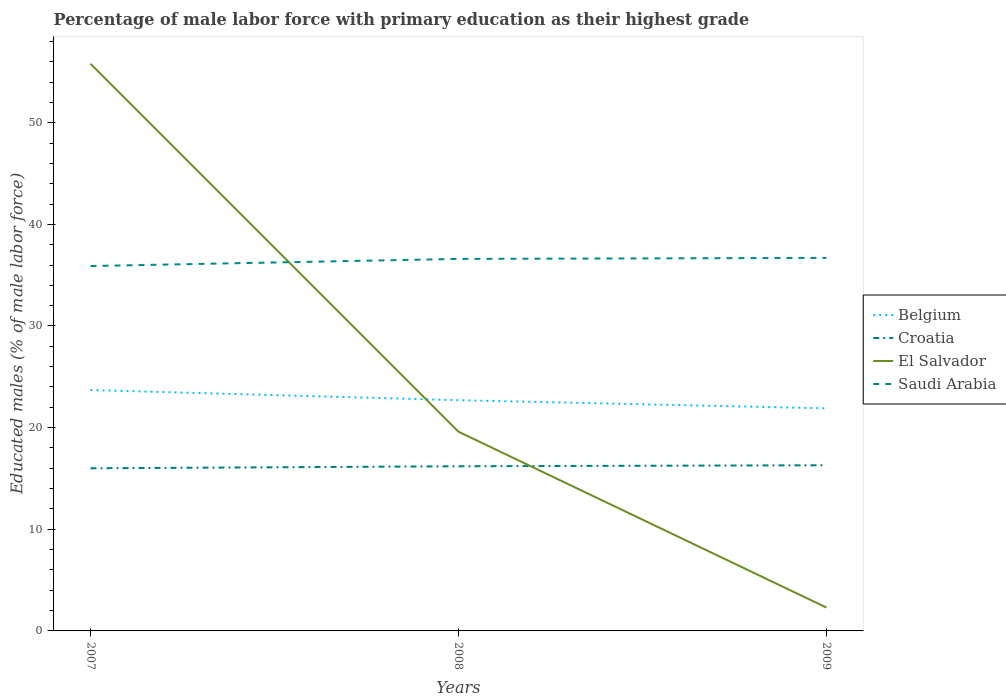How many different coloured lines are there?
Your answer should be compact. 4. Is the number of lines equal to the number of legend labels?
Your response must be concise. Yes. What is the total percentage of male labor force with primary education in Saudi Arabia in the graph?
Ensure brevity in your answer.  -0.8. What is the difference between the highest and the second highest percentage of male labor force with primary education in El Salvador?
Ensure brevity in your answer.  53.5. Does the graph contain any zero values?
Keep it short and to the point. No. Does the graph contain grids?
Offer a very short reply. No. How are the legend labels stacked?
Offer a very short reply. Vertical. What is the title of the graph?
Provide a succinct answer. Percentage of male labor force with primary education as their highest grade. What is the label or title of the X-axis?
Ensure brevity in your answer.  Years. What is the label or title of the Y-axis?
Ensure brevity in your answer.  Educated males (% of male labor force). What is the Educated males (% of male labor force) in Belgium in 2007?
Offer a terse response. 23.7. What is the Educated males (% of male labor force) in El Salvador in 2007?
Keep it short and to the point. 55.8. What is the Educated males (% of male labor force) in Saudi Arabia in 2007?
Make the answer very short. 35.9. What is the Educated males (% of male labor force) of Belgium in 2008?
Provide a short and direct response. 22.7. What is the Educated males (% of male labor force) of Croatia in 2008?
Offer a very short reply. 16.2. What is the Educated males (% of male labor force) of El Salvador in 2008?
Offer a terse response. 19.6. What is the Educated males (% of male labor force) in Saudi Arabia in 2008?
Your answer should be very brief. 36.6. What is the Educated males (% of male labor force) in Belgium in 2009?
Provide a short and direct response. 21.9. What is the Educated males (% of male labor force) of Croatia in 2009?
Provide a short and direct response. 16.3. What is the Educated males (% of male labor force) in El Salvador in 2009?
Provide a short and direct response. 2.3. What is the Educated males (% of male labor force) in Saudi Arabia in 2009?
Give a very brief answer. 36.7. Across all years, what is the maximum Educated males (% of male labor force) of Belgium?
Provide a succinct answer. 23.7. Across all years, what is the maximum Educated males (% of male labor force) in Croatia?
Your answer should be very brief. 16.3. Across all years, what is the maximum Educated males (% of male labor force) of El Salvador?
Your response must be concise. 55.8. Across all years, what is the maximum Educated males (% of male labor force) of Saudi Arabia?
Your answer should be very brief. 36.7. Across all years, what is the minimum Educated males (% of male labor force) of Belgium?
Your answer should be compact. 21.9. Across all years, what is the minimum Educated males (% of male labor force) in Croatia?
Provide a succinct answer. 16. Across all years, what is the minimum Educated males (% of male labor force) of El Salvador?
Provide a succinct answer. 2.3. Across all years, what is the minimum Educated males (% of male labor force) in Saudi Arabia?
Keep it short and to the point. 35.9. What is the total Educated males (% of male labor force) of Belgium in the graph?
Ensure brevity in your answer.  68.3. What is the total Educated males (% of male labor force) in Croatia in the graph?
Offer a terse response. 48.5. What is the total Educated males (% of male labor force) of El Salvador in the graph?
Your answer should be very brief. 77.7. What is the total Educated males (% of male labor force) in Saudi Arabia in the graph?
Your answer should be very brief. 109.2. What is the difference between the Educated males (% of male labor force) of El Salvador in 2007 and that in 2008?
Provide a succinct answer. 36.2. What is the difference between the Educated males (% of male labor force) of El Salvador in 2007 and that in 2009?
Make the answer very short. 53.5. What is the difference between the Educated males (% of male labor force) in Croatia in 2008 and that in 2009?
Make the answer very short. -0.1. What is the difference between the Educated males (% of male labor force) of El Salvador in 2008 and that in 2009?
Your answer should be very brief. 17.3. What is the difference between the Educated males (% of male labor force) in Saudi Arabia in 2008 and that in 2009?
Offer a terse response. -0.1. What is the difference between the Educated males (% of male labor force) in Croatia in 2007 and the Educated males (% of male labor force) in El Salvador in 2008?
Offer a very short reply. -3.6. What is the difference between the Educated males (% of male labor force) in Croatia in 2007 and the Educated males (% of male labor force) in Saudi Arabia in 2008?
Provide a short and direct response. -20.6. What is the difference between the Educated males (% of male labor force) in El Salvador in 2007 and the Educated males (% of male labor force) in Saudi Arabia in 2008?
Your response must be concise. 19.2. What is the difference between the Educated males (% of male labor force) in Belgium in 2007 and the Educated males (% of male labor force) in El Salvador in 2009?
Offer a very short reply. 21.4. What is the difference between the Educated males (% of male labor force) of Belgium in 2007 and the Educated males (% of male labor force) of Saudi Arabia in 2009?
Make the answer very short. -13. What is the difference between the Educated males (% of male labor force) of Croatia in 2007 and the Educated males (% of male labor force) of Saudi Arabia in 2009?
Your response must be concise. -20.7. What is the difference between the Educated males (% of male labor force) of El Salvador in 2007 and the Educated males (% of male labor force) of Saudi Arabia in 2009?
Provide a short and direct response. 19.1. What is the difference between the Educated males (% of male labor force) in Belgium in 2008 and the Educated males (% of male labor force) in Croatia in 2009?
Offer a very short reply. 6.4. What is the difference between the Educated males (% of male labor force) in Belgium in 2008 and the Educated males (% of male labor force) in El Salvador in 2009?
Keep it short and to the point. 20.4. What is the difference between the Educated males (% of male labor force) of Belgium in 2008 and the Educated males (% of male labor force) of Saudi Arabia in 2009?
Offer a terse response. -14. What is the difference between the Educated males (% of male labor force) of Croatia in 2008 and the Educated males (% of male labor force) of Saudi Arabia in 2009?
Your response must be concise. -20.5. What is the difference between the Educated males (% of male labor force) in El Salvador in 2008 and the Educated males (% of male labor force) in Saudi Arabia in 2009?
Offer a very short reply. -17.1. What is the average Educated males (% of male labor force) in Belgium per year?
Your answer should be compact. 22.77. What is the average Educated males (% of male labor force) of Croatia per year?
Your response must be concise. 16.17. What is the average Educated males (% of male labor force) of El Salvador per year?
Make the answer very short. 25.9. What is the average Educated males (% of male labor force) in Saudi Arabia per year?
Provide a short and direct response. 36.4. In the year 2007, what is the difference between the Educated males (% of male labor force) of Belgium and Educated males (% of male labor force) of Croatia?
Your answer should be compact. 7.7. In the year 2007, what is the difference between the Educated males (% of male labor force) in Belgium and Educated males (% of male labor force) in El Salvador?
Make the answer very short. -32.1. In the year 2007, what is the difference between the Educated males (% of male labor force) of Croatia and Educated males (% of male labor force) of El Salvador?
Your answer should be compact. -39.8. In the year 2007, what is the difference between the Educated males (% of male labor force) in Croatia and Educated males (% of male labor force) in Saudi Arabia?
Your response must be concise. -19.9. In the year 2007, what is the difference between the Educated males (% of male labor force) in El Salvador and Educated males (% of male labor force) in Saudi Arabia?
Provide a short and direct response. 19.9. In the year 2008, what is the difference between the Educated males (% of male labor force) in Belgium and Educated males (% of male labor force) in Croatia?
Give a very brief answer. 6.5. In the year 2008, what is the difference between the Educated males (% of male labor force) in Belgium and Educated males (% of male labor force) in El Salvador?
Keep it short and to the point. 3.1. In the year 2008, what is the difference between the Educated males (% of male labor force) of Croatia and Educated males (% of male labor force) of El Salvador?
Your answer should be compact. -3.4. In the year 2008, what is the difference between the Educated males (% of male labor force) in Croatia and Educated males (% of male labor force) in Saudi Arabia?
Offer a terse response. -20.4. In the year 2008, what is the difference between the Educated males (% of male labor force) of El Salvador and Educated males (% of male labor force) of Saudi Arabia?
Your answer should be very brief. -17. In the year 2009, what is the difference between the Educated males (% of male labor force) in Belgium and Educated males (% of male labor force) in El Salvador?
Ensure brevity in your answer.  19.6. In the year 2009, what is the difference between the Educated males (% of male labor force) in Belgium and Educated males (% of male labor force) in Saudi Arabia?
Make the answer very short. -14.8. In the year 2009, what is the difference between the Educated males (% of male labor force) in Croatia and Educated males (% of male labor force) in El Salvador?
Provide a short and direct response. 14. In the year 2009, what is the difference between the Educated males (% of male labor force) in Croatia and Educated males (% of male labor force) in Saudi Arabia?
Keep it short and to the point. -20.4. In the year 2009, what is the difference between the Educated males (% of male labor force) in El Salvador and Educated males (% of male labor force) in Saudi Arabia?
Keep it short and to the point. -34.4. What is the ratio of the Educated males (% of male labor force) of Belgium in 2007 to that in 2008?
Keep it short and to the point. 1.04. What is the ratio of the Educated males (% of male labor force) in El Salvador in 2007 to that in 2008?
Give a very brief answer. 2.85. What is the ratio of the Educated males (% of male labor force) in Saudi Arabia in 2007 to that in 2008?
Your answer should be very brief. 0.98. What is the ratio of the Educated males (% of male labor force) in Belgium in 2007 to that in 2009?
Your response must be concise. 1.08. What is the ratio of the Educated males (% of male labor force) of Croatia in 2007 to that in 2009?
Ensure brevity in your answer.  0.98. What is the ratio of the Educated males (% of male labor force) of El Salvador in 2007 to that in 2009?
Your response must be concise. 24.26. What is the ratio of the Educated males (% of male labor force) of Saudi Arabia in 2007 to that in 2009?
Ensure brevity in your answer.  0.98. What is the ratio of the Educated males (% of male labor force) in Belgium in 2008 to that in 2009?
Your answer should be very brief. 1.04. What is the ratio of the Educated males (% of male labor force) in El Salvador in 2008 to that in 2009?
Provide a short and direct response. 8.52. What is the ratio of the Educated males (% of male labor force) in Saudi Arabia in 2008 to that in 2009?
Make the answer very short. 1. What is the difference between the highest and the second highest Educated males (% of male labor force) of Croatia?
Your answer should be compact. 0.1. What is the difference between the highest and the second highest Educated males (% of male labor force) in El Salvador?
Make the answer very short. 36.2. What is the difference between the highest and the lowest Educated males (% of male labor force) of Belgium?
Your answer should be very brief. 1.8. What is the difference between the highest and the lowest Educated males (% of male labor force) of El Salvador?
Offer a very short reply. 53.5. What is the difference between the highest and the lowest Educated males (% of male labor force) of Saudi Arabia?
Your answer should be compact. 0.8. 